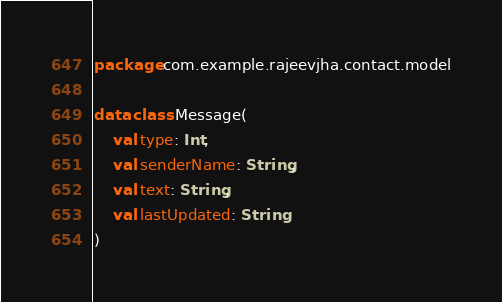<code> <loc_0><loc_0><loc_500><loc_500><_Kotlin_>package com.example.rajeevjha.contact.model

data class Message(
    val type: Int,
    val senderName: String,
    val text: String,
    val lastUpdated: String
)</code> 